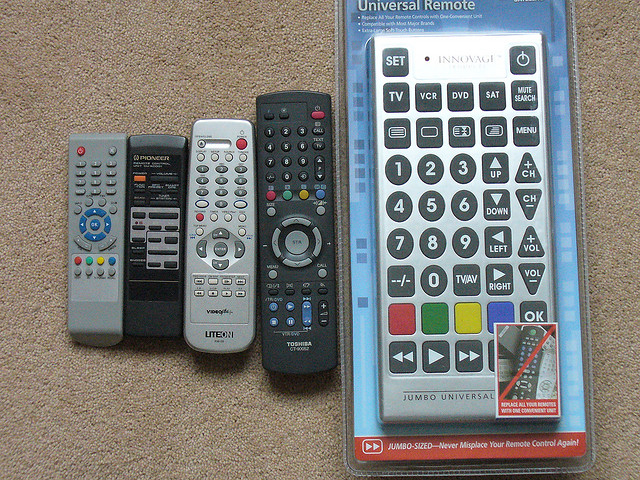Please identify all text content in this image. E J 5 control JUMBO UNIVERSAL JUMBO OK VOL RIGHT 0 VOL LEFT 9 8 7 6 5 4 DOWN UP 3 2 1 CH CH MENU SEARCH MUTE SAT DVD VCR TV SET INNOVAGI Remote Universal 